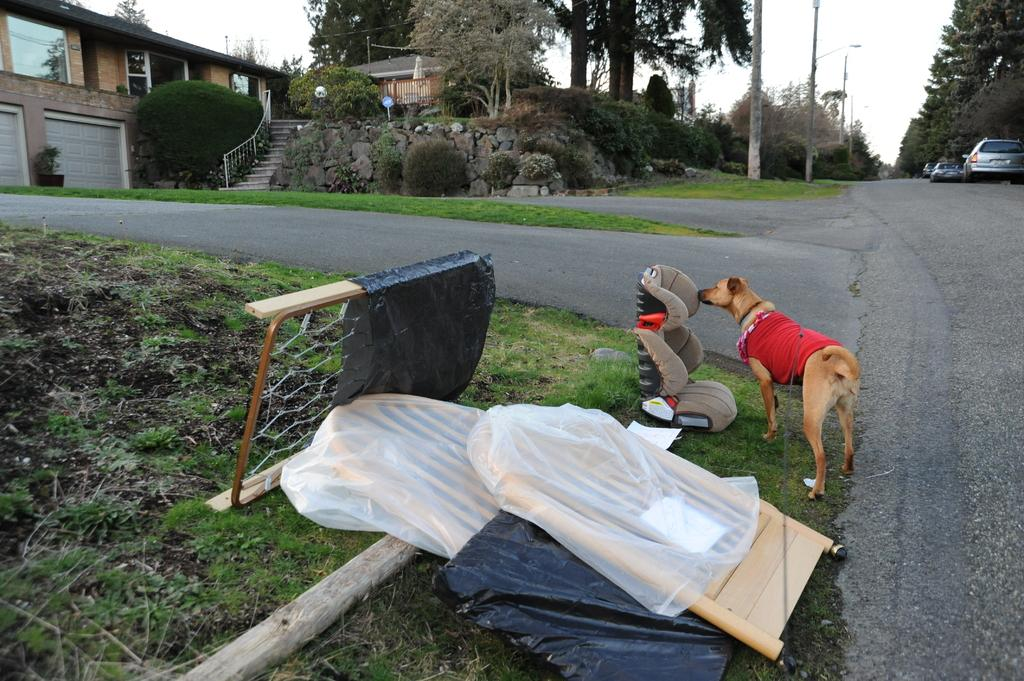What is on the grass in the image? There are objects on the grass in the image. What type of animal is present in the image? There is a dog in the image. What can be seen on the road in the image? There are vehicles on the road in the image. Where are the vehicles located? The vehicles are on a road. What is visible in the background of the image? There is a house and trees in the background of the image. What type of meat is the dog eating in the image? There is no meat present in the image; the dog is not eating anything. What kind of shoe is visible on the grass in the image? There is no shoe visible on the grass in the image. 